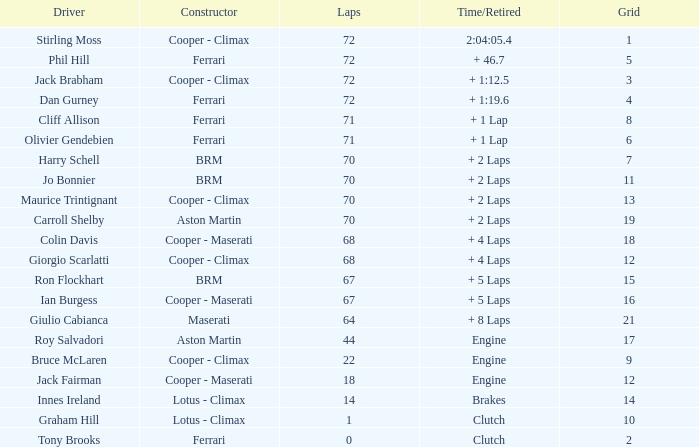Would you be able to parse every entry in this table? {'header': ['Driver', 'Constructor', 'Laps', 'Time/Retired', 'Grid'], 'rows': [['Stirling Moss', 'Cooper - Climax', '72', '2:04:05.4', '1'], ['Phil Hill', 'Ferrari', '72', '+ 46.7', '5'], ['Jack Brabham', 'Cooper - Climax', '72', '+ 1:12.5', '3'], ['Dan Gurney', 'Ferrari', '72', '+ 1:19.6', '4'], ['Cliff Allison', 'Ferrari', '71', '+ 1 Lap', '8'], ['Olivier Gendebien', 'Ferrari', '71', '+ 1 Lap', '6'], ['Harry Schell', 'BRM', '70', '+ 2 Laps', '7'], ['Jo Bonnier', 'BRM', '70', '+ 2 Laps', '11'], ['Maurice Trintignant', 'Cooper - Climax', '70', '+ 2 Laps', '13'], ['Carroll Shelby', 'Aston Martin', '70', '+ 2 Laps', '19'], ['Colin Davis', 'Cooper - Maserati', '68', '+ 4 Laps', '18'], ['Giorgio Scarlatti', 'Cooper - Climax', '68', '+ 4 Laps', '12'], ['Ron Flockhart', 'BRM', '67', '+ 5 Laps', '15'], ['Ian Burgess', 'Cooper - Maserati', '67', '+ 5 Laps', '16'], ['Giulio Cabianca', 'Maserati', '64', '+ 8 Laps', '21'], ['Roy Salvadori', 'Aston Martin', '44', 'Engine', '17'], ['Bruce McLaren', 'Cooper - Climax', '22', 'Engine', '9'], ['Jack Fairman', 'Cooper - Maserati', '18', 'Engine', '12'], ['Innes Ireland', 'Lotus - Climax', '14', 'Brakes', '14'], ['Graham Hill', 'Lotus - Climax', '1', 'Clutch', '10'], ['Tony Brooks', 'Ferrari', '0', 'Clutch', '2']]} What is the duration/retirement for phil hill with more than 67 laps and a grade less than 18? + 46.7. 